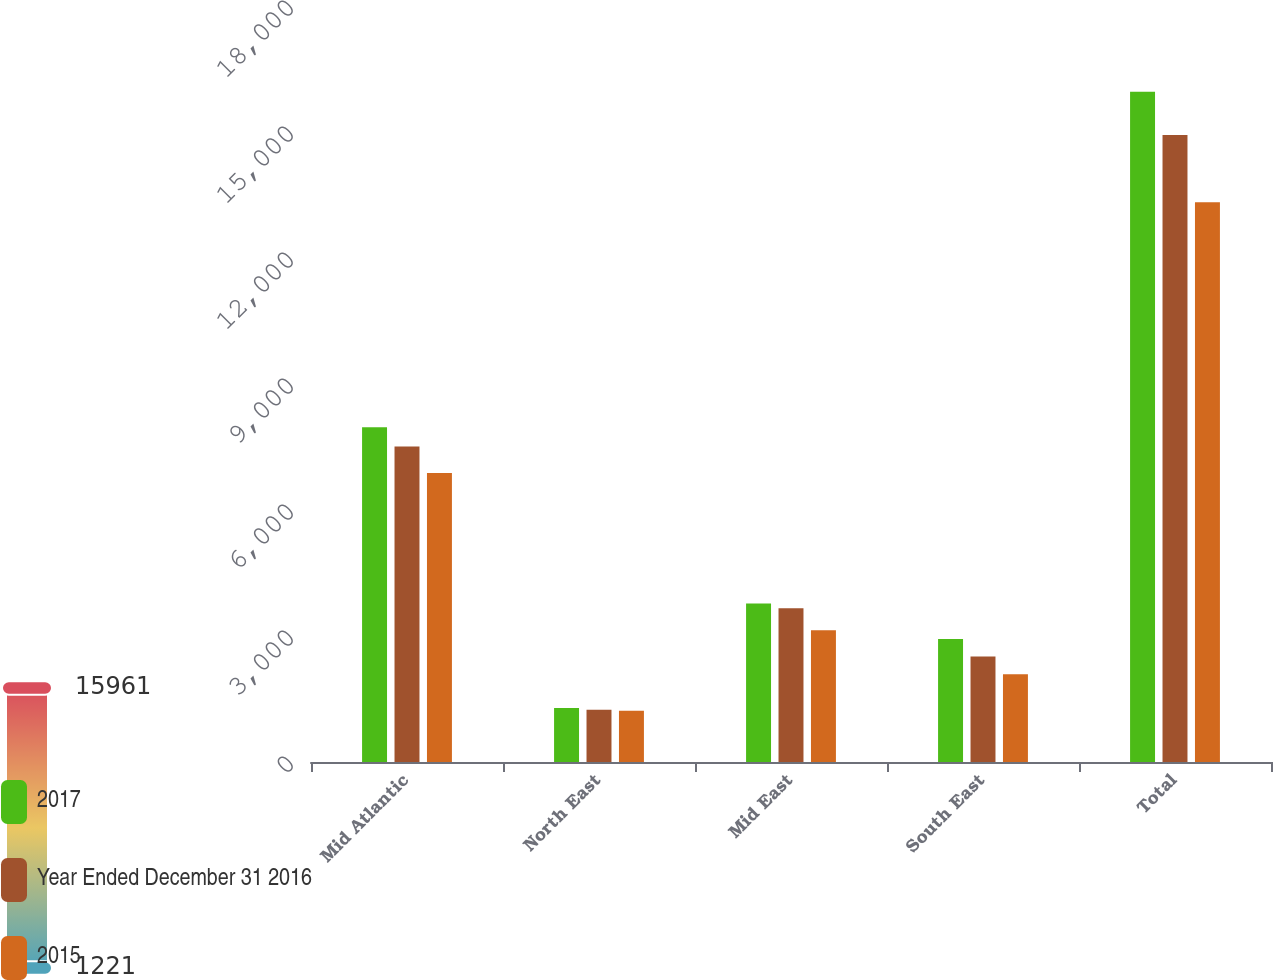Convert chart to OTSL. <chart><loc_0><loc_0><loc_500><loc_500><stacked_bar_chart><ecel><fcel>Mid Atlantic<fcel>North East<fcel>Mid East<fcel>South East<fcel>Total<nl><fcel>2017<fcel>7971<fcel>1288<fcel>3772<fcel>2930<fcel>15961<nl><fcel>Year Ended December 31 2016<fcel>7512<fcel>1246<fcel>3658<fcel>2512<fcel>14928<nl><fcel>2015<fcel>6879<fcel>1221<fcel>3137<fcel>2089<fcel>13326<nl></chart> 